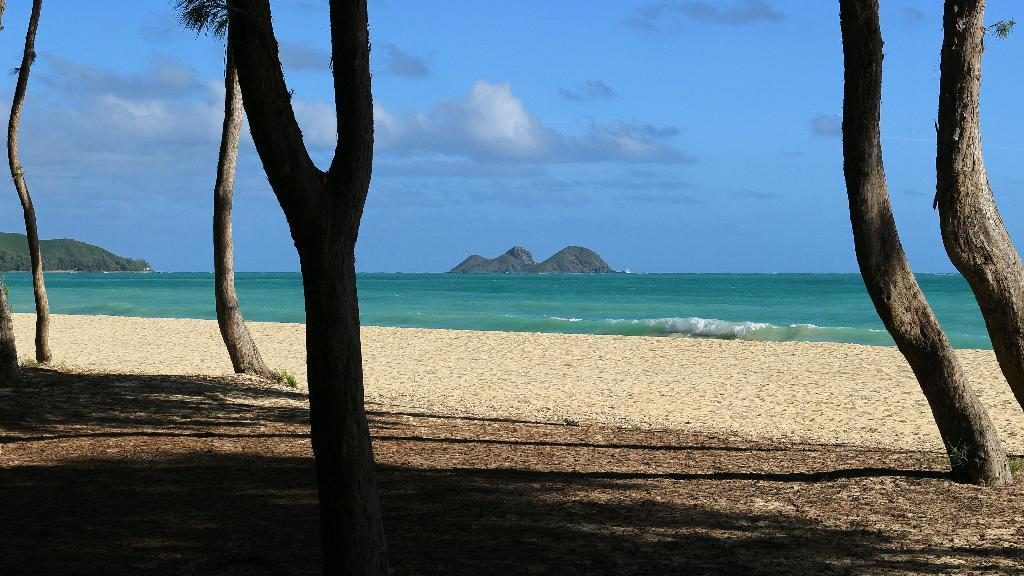What type of natural feature is the main subject of the image? There is an ocean in the image. What other natural features can be seen in the image? Mountains and trees are visible in the image. What type of terrain is present near the ocean? There is sand visible in the image. What is visible in the sky in the image? Clouds are present in the sky in the image. Where is the desk located in the image? There is no desk present in the image; it features natural landscapes. What type of salt can be seen on the sand in the image? There is no salt visible on the sand in the image. 